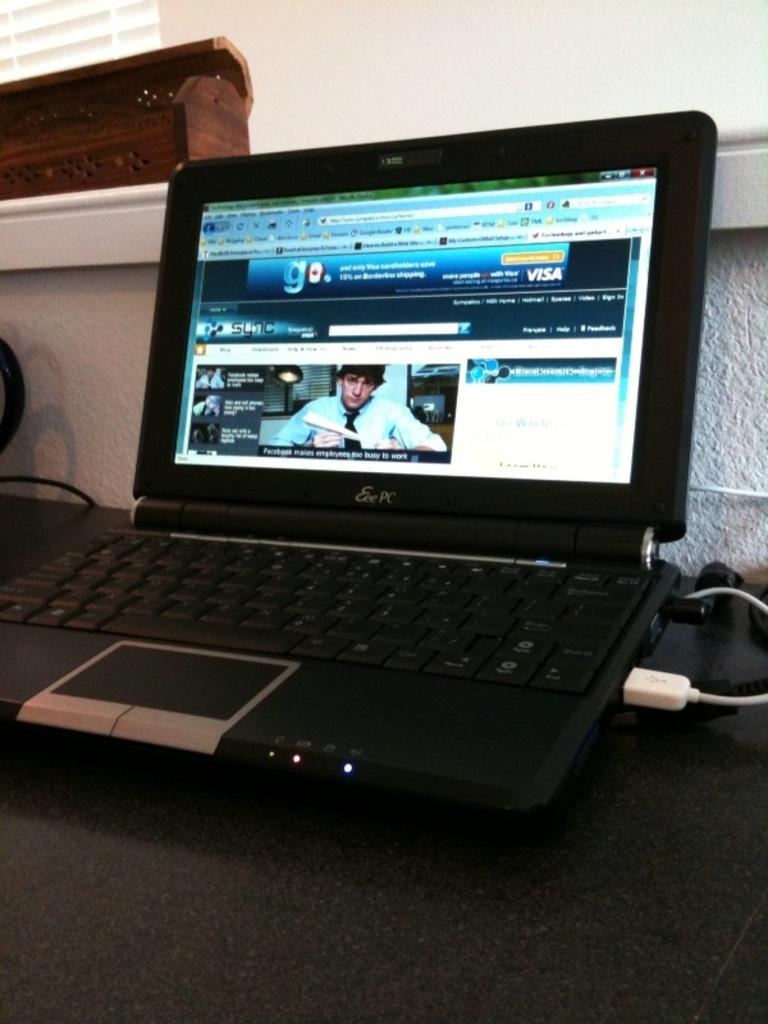<image>
Relay a brief, clear account of the picture shown. An open laptop with a banner advertisement for VISA on the screen 